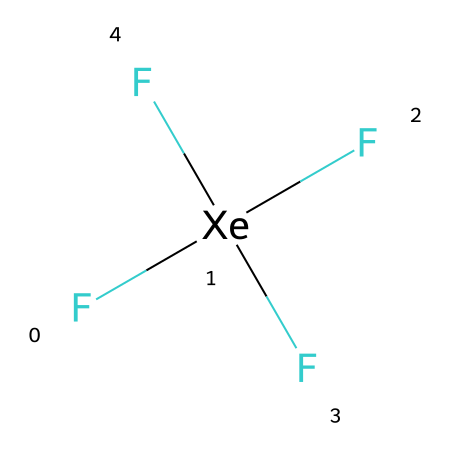What is the central atom in xenon tetrafluoride? The central atom is indicated by its position in the structure, surrounded by electron pairs and bonded to four fluorine atoms. In this case, the central atom is xenon (Xe).
Answer: xenon How many fluorine atoms are bonded to the xenon atom? The structure shows four fluorine (F) atoms directly bonded to the xenon atom. Each fluorine is shown in parentheses, confirming that they are all attached.
Answer: four Is xenon tetrafluoride a hypervalent compound? By definition, hypervalent compounds feature a central atom that can form more than four bonds. Since xenon in this compound is bonded to four fluorine atoms, it is indeed classified as hypervalent.
Answer: yes What is the hybridization of the xenon atom in this compound? To determine hybridization, we consider the bonded atoms and lone pairs around the central xenon atom. With four bonded fluorine atoms and no lone pairs, xenon exhibits sp³d hybridization.
Answer: sp³d What is the molecular geometry of xenon tetrafluoride? The arrangement of the bonded fluorine atoms around the central xenon atom, as indicated by its hybridization (sp³d), suggests that the molecular geometry is square planar.
Answer: square planar What characteristic of xenon tetrafluoride makes it useful in food packaging technology? The reactivity of xenon tetrafluoride, along with its ability to inhibit microbial growth due to its strong oxidizing properties, contributes to its use in food packaging technology.
Answer: strong oxidizing properties 